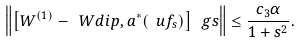Convert formula to latex. <formula><loc_0><loc_0><loc_500><loc_500>\left \| \left [ W ^ { ( 1 ) } - \ W d i p , a ^ { * } ( \ u f _ { s } ) \right ] \ g s \right \| \leq \frac { c _ { 3 } \alpha } { 1 + s ^ { 2 } } .</formula> 